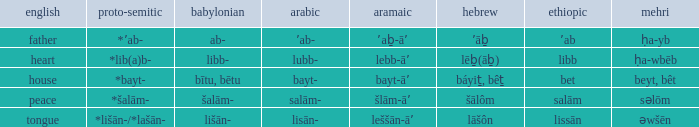If in english it is heart, what is it in hebrew? Lēḇ(āḇ). 